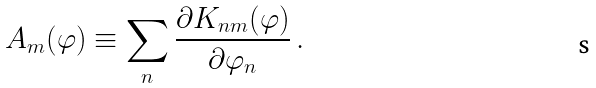<formula> <loc_0><loc_0><loc_500><loc_500>A _ { m } ( \varphi ) \equiv \sum _ { n } \frac { \partial K _ { n m } ( \varphi ) } { \partial \varphi _ { n } } \, .</formula> 